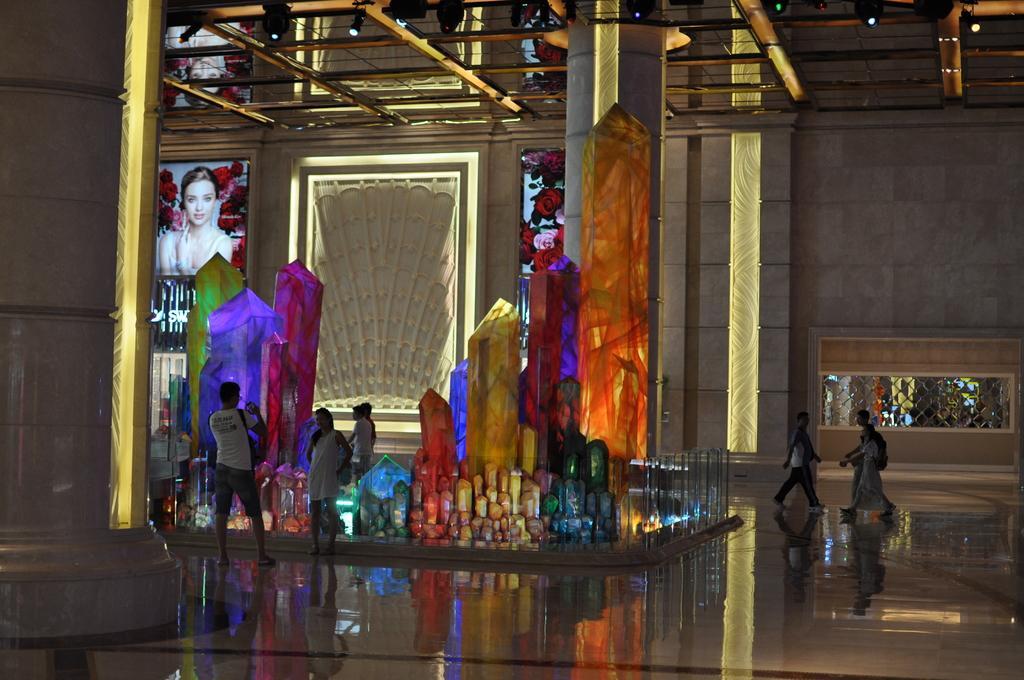Describe this image in one or two sentences. In this picture I can see a number of people on the surface. I can see light arrangements on the roof. I can see the decoration on the left side. 